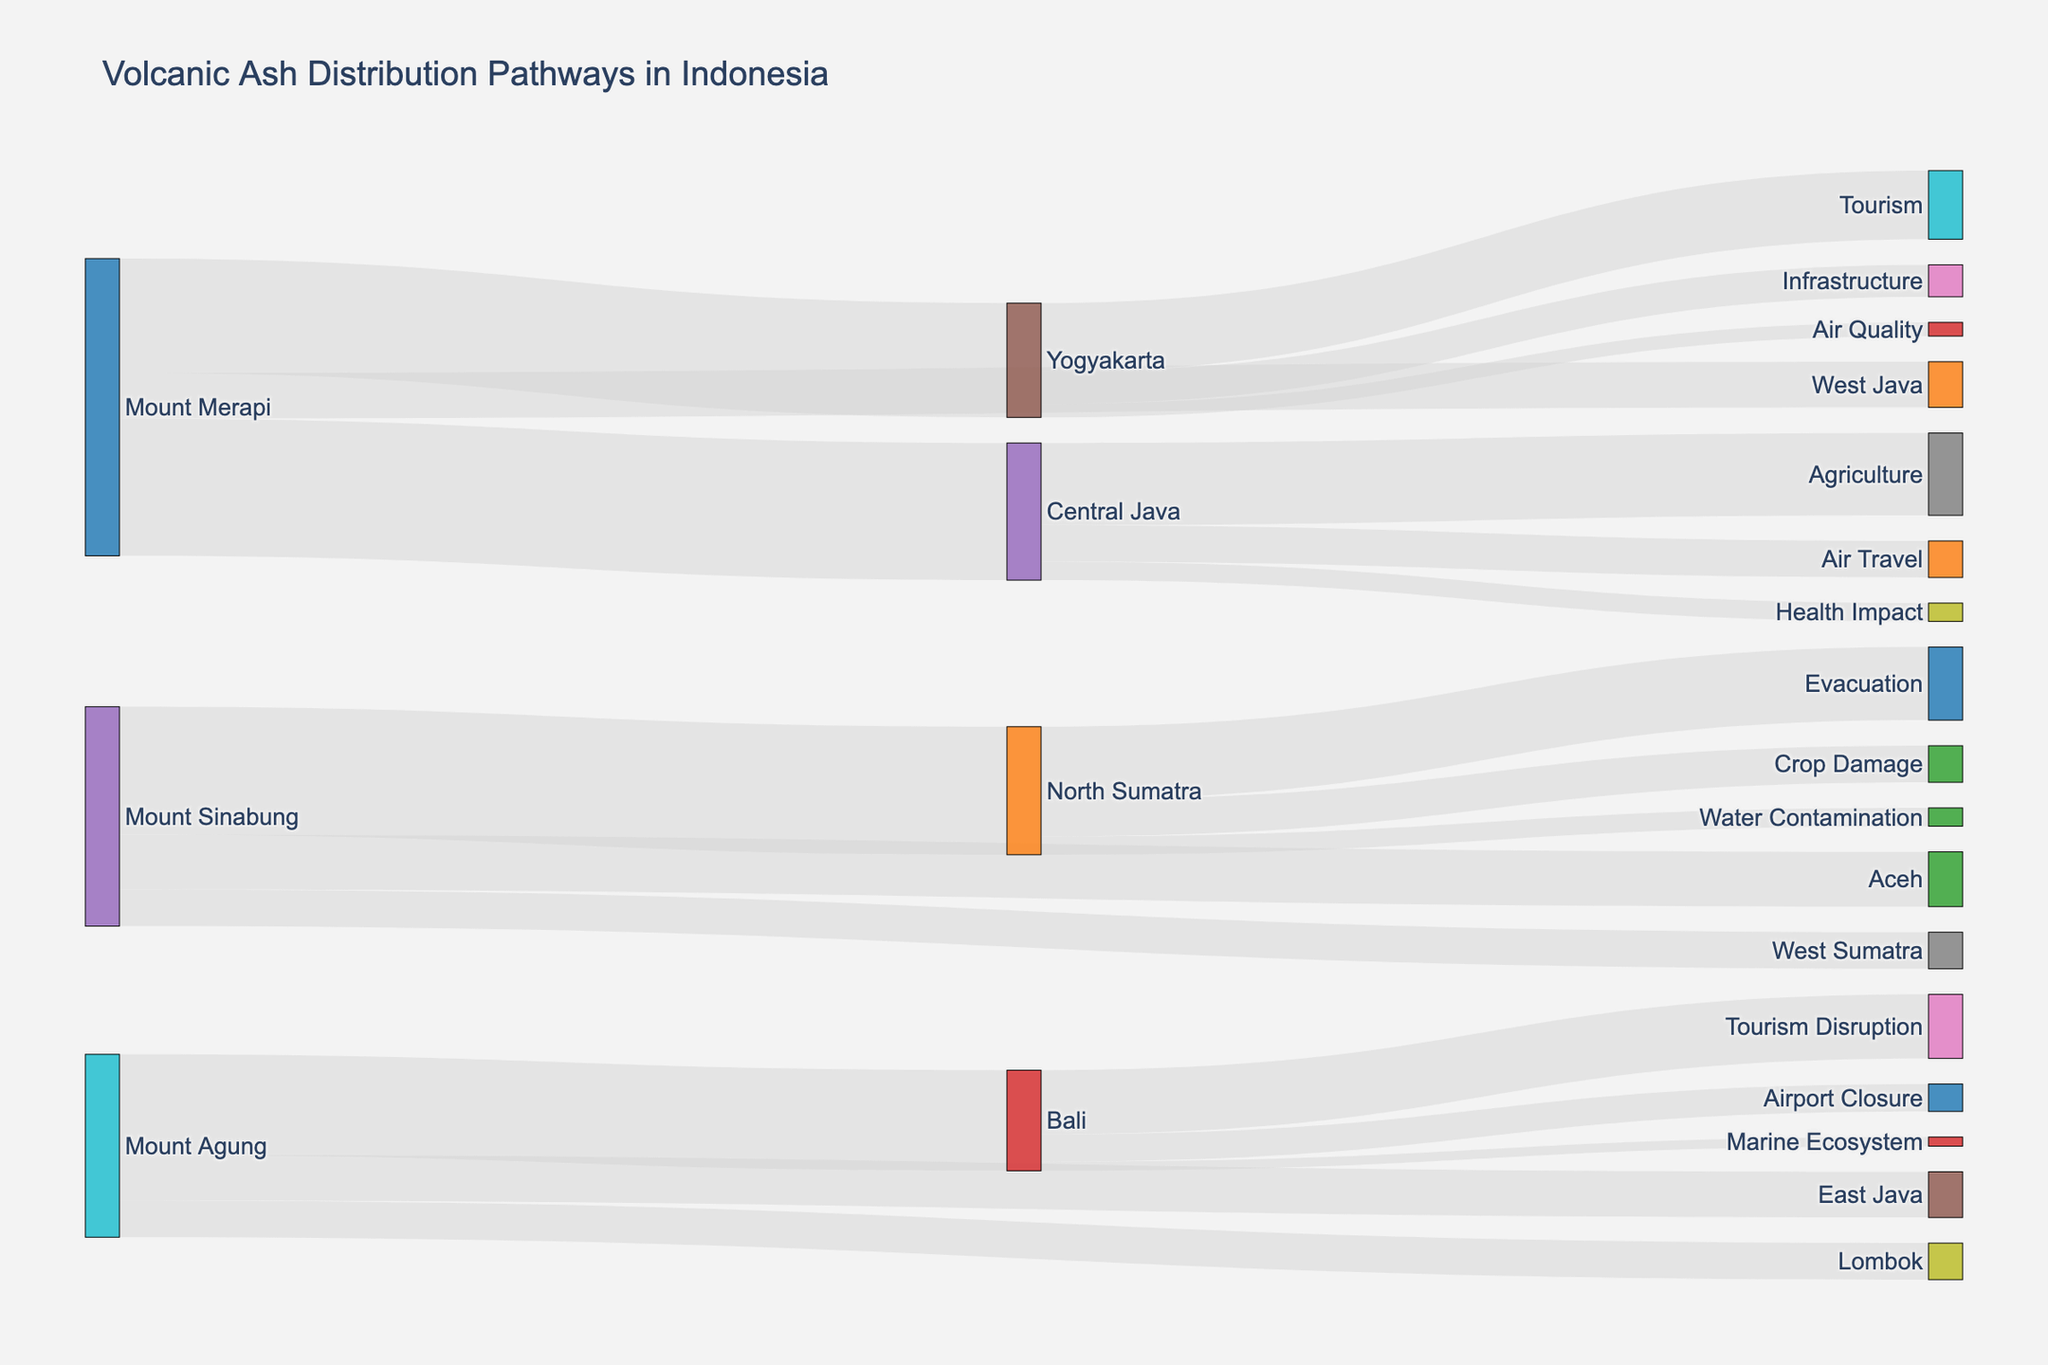What’s the main title of the Sankey Diagram? The title will be clearly displayed at the top of the Sankey Diagram. You can read it directly.
Answer: Volcanic Ash Distribution Pathways in Indonesia How many connections are there between Mount Sinabung and all its targets combined? There are three connections from Mount Sinabung—North Sumatra, Aceh, and West Sumatra. Count each link.
Answer: 3 Which region receives the largest amount of volcanic ash from Mount Merapi? Among Central Java, Yogyakarta, and West Java, compare the values of volcanic ash from Mount Merapi. Central Java gets 3000, Yogyakarta gets 2500, and West Java gets 1000. Central Java has the highest value.
Answer: Central Java What’s the total amount of volcanic ash distributed by Mount Agung? Add the values of volcanic ash distributed by Mount Agung: Bali (2200), East Java (1000), and Lombok (800). The total is 2200 + 1000 + 800 = 4000.
Answer: 4000 Which target receives the least volcanic ash from any volcano? List out all targets and their corresponding values, then identify the smallest value. Marine Ecosystem gets 200 units from Bali, which is the least.
Answer: Marine Ecosystem What’s the combined ash distribution effect on Tourism from all regions? Sum the values that affect Tourism: Yogyakarta (1500) and Bali (1400). The combined value is 1500 + 1400 = 2900.
Answer: 2900 Which volcano affects the largest number of regions? Compare the number of regions affected by each volcano: Mount Merapi (3), Mount Sinabung (3), and Mount Agung (3). They each affect 3 regions.
Answer: Mount Merapi, Mount Sinabung, Mount Agung What is the proportion of volcanic ash from Mount Sinabung that is received by North Sumatra? Divide the value received by North Sumatra (2800) by the total volcanic ash from Mount Sinabung (2800 + 1200 + 800 = 4800). The proportion is 2800/4800 = 0.583, or 58.3%.
Answer: 58.3% Which region experiences the highest number of impacts (subcategories) listed in the diagram? Compare the number of impact subcategories connected to each region. Central Java, Yogyakarta, North Sumatra, and Bali each have 3 subcategories connected to them.
Answer: Central Java, Yogyakarta, North Sumatra, Bali How many nodes are presented in the Sankey diagram? Nodes include both sources and targets. Count the unique elements in the combination of sources and targets. There are 15 unique nodes in total.
Answer: 15 